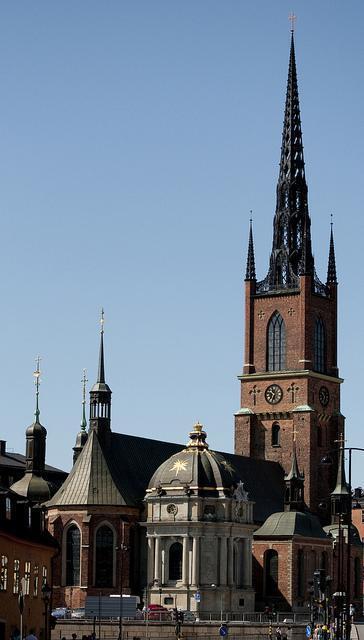What design is next to the clock on the largest building?
Indicate the correct response and explain using: 'Answer: answer
Rationale: rationale.'
Options: Star, wolf sigil, cross, hexagon. Answer: cross.
Rationale: The tallest structure on the largest building is a tower with a gold cross at the top. What color are the little stars on top of the dome building at the church?
Indicate the correct response by choosing from the four available options to answer the question.
Options: Black, white, gold, blue. Gold. 